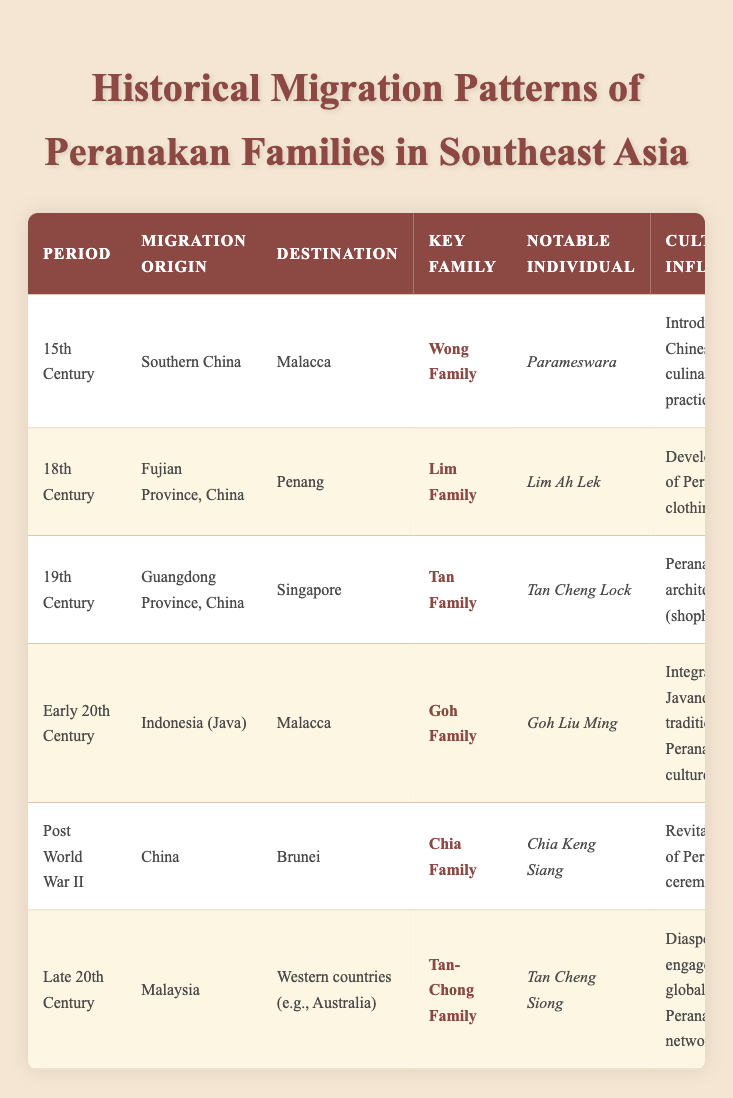What was the migration origin of the Tan Family? According to the table, the Tan Family migrated from Guangdong Province, China during the 19th Century.
Answer: Guangdong Province, China Which family was associated with the introduction of Chinese culinary practices? The Wong Family, noted for their migration from Southern China to Malacca in the 15th Century, was associated with the introduction of Chinese culinary practices.
Answer: Wong Family What economic activity was common among the Peranakan families in the late 20th century? The Tan-Chong Family engaged in the food business and cultural promotion, which aligns with the economic activities of other families in their period.
Answer: Food business and cultural promotion Did the Goh Family influence Peranakan culture? Yes, the Goh Family integrated Javanese traditions into Peranakan culture during their migration from Indonesia (Java) to Malacca in the early 20th Century.
Answer: Yes What is the average period of migration for the families listed? The periods listed are 15th Century, 18th Century, 19th Century, Early 20th Century, Post World War II, and Late 20th Century. Converting these periods to numerical values (15, 18, 19, 20, 1945, 1970) and averaging gives (15 + 18 + 19 + 20 + 1945 + 1970) / 6 ≈ 272. This means the average period of migration for the families would be approximately in the late 20th Century, considering the median of these periods.
Answer: Late 20th Century Which notable individual is linked with the Lim Family, and what was their contribution? Lim Ah Lek is the notable individual linked with the Lim Family, who contributed to the development of Peranakan clothing styles during the migration from Fujian Province, China to Penang in the 18th Century.
Answer: Lim Ah Lek; clothing styles development Which destination had the highest number of key families associated with migration? Malacca is listed as the destination for two key families: the Wong Family in the 15th Century and the Goh Family in the Early 20th Century.
Answer: Malacca What cultural influence is associated with the migration of the Chia Family to Brunei? The Chia Family is associated with the revitalization of Peranakan ceremonies after migrating from China to Brunei in the Post World War II period.
Answer: Revitalization of ceremonies In which century did the Goh Family migrate and what was their economic activity? The Goh Family migrated in the Early 20th Century and their economic activity included rice farming and spice trade.
Answer: Early 20th Century; rice farming and spice trade What are the notable economic activities of the Lim Family? The Lim Family engaged in opium trade and agriculture during their migration from Fujian Province, China to Penang in the 18th Century.
Answer: Opium trade and agriculture Was there any cultural influence related to Peranakan architecture? Yes, the Tan Family has a cultural influence pertaining to Peranakan architecture, specifically the design of shophouses, during their migration from Guangdong Province, China to Singapore in the 19th Century.
Answer: Yes 